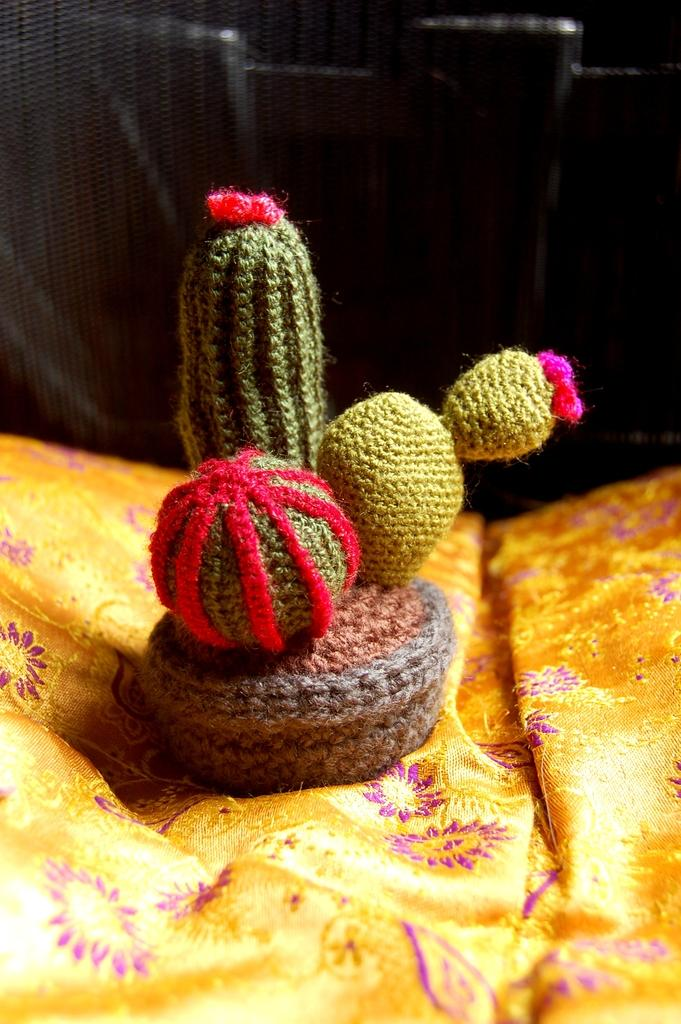What type of material is used to create the object in the image? The object in the image is made of wool. What is the object placed on in the image? The woolen object is on a yellow cloth. What colors can be seen on the woolen object? The woolen object has green, red, and pink colors. How would you describe the overall appearance of the image? The background of the image is dark. Can you see a pig in the image? No, there is no pig present in the image. Is there a fire burning in the image? No, there is no fire present in the image. 